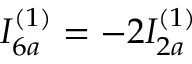<formula> <loc_0><loc_0><loc_500><loc_500>I _ { 6 a } ^ { ( 1 ) } = - 2 I _ { 2 a } ^ { ( 1 ) }</formula> 